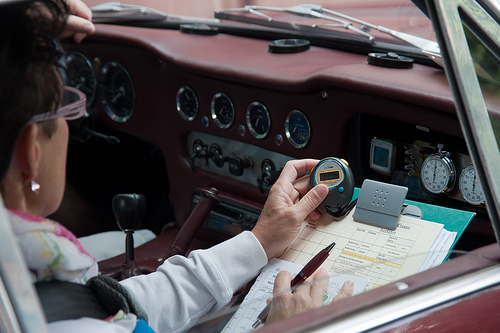Please provide a short description for this region: [0.0, 0.31, 0.19, 0.44]. Here, you can see a woman wearing translucent pink glasses. The glasses have a slight cat-eye design, which gives a trendy and vintage look simultaneously. 